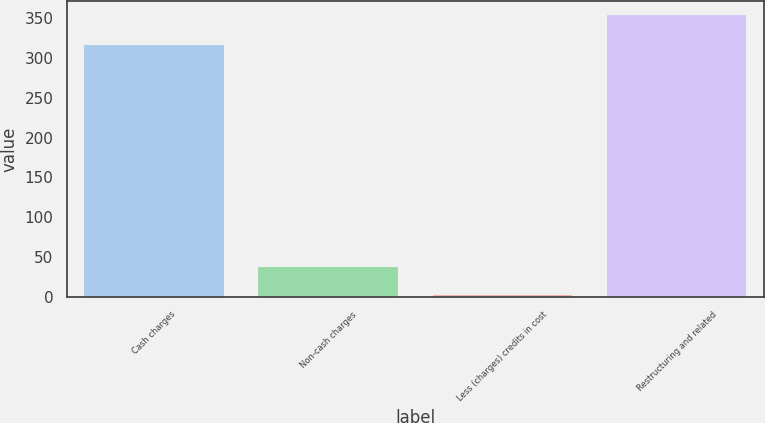Convert chart to OTSL. <chart><loc_0><loc_0><loc_500><loc_500><bar_chart><fcel>Cash charges<fcel>Non-cash charges<fcel>Less (charges) credits in cost<fcel>Restructuring and related<nl><fcel>317<fcel>37.2<fcel>2<fcel>354<nl></chart> 